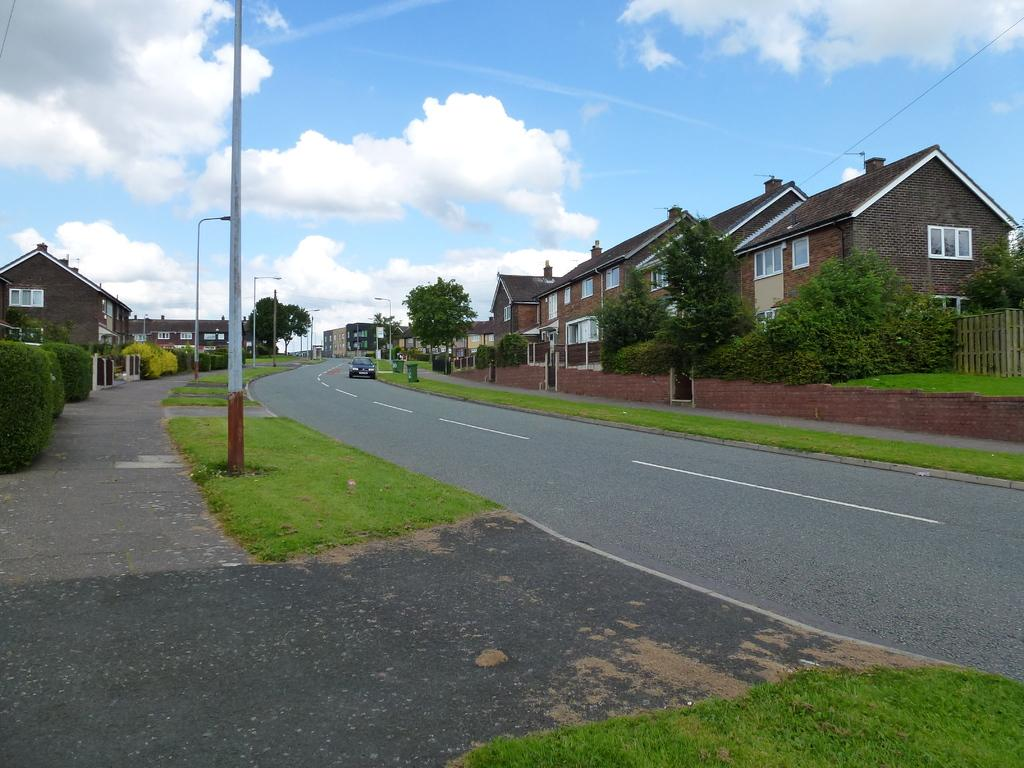What is happening in the image? There is a vehicle moving on the road in the image. What can be seen on both sides of the road? There are buildings, trees, and grass on both sides of the road. What type of lighting is present on both sides of the road? Street lights are present on both sides of the road. What is visible in the background of the image? The sky is visible in the background of the image. Can you tell me how many buttons are on the horse in the image? There is no horse or button present in the image. 